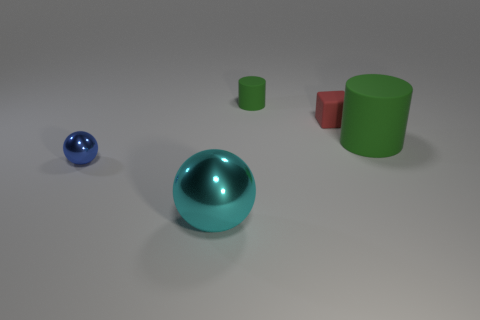Is there anything else that is the same shape as the small red object?
Provide a succinct answer. No. How many other things are there of the same color as the small rubber cylinder?
Ensure brevity in your answer.  1. There is a metallic sphere left of the cyan metal ball; is it the same size as the tiny cylinder?
Make the answer very short. Yes. Are there any red matte objects of the same size as the blue ball?
Make the answer very short. Yes. The tiny object that is to the left of the large sphere is what color?
Your answer should be very brief. Blue. There is a small thing that is both to the right of the large metallic object and on the left side of the small red block; what shape is it?
Ensure brevity in your answer.  Cylinder. How many blue shiny objects are the same shape as the red thing?
Your response must be concise. 0. What number of gray rubber objects are there?
Keep it short and to the point. 0. There is a object that is both on the left side of the small green cylinder and right of the small blue metallic object; what is its size?
Ensure brevity in your answer.  Large. What is the shape of the blue object that is the same size as the rubber cube?
Provide a succinct answer. Sphere. 